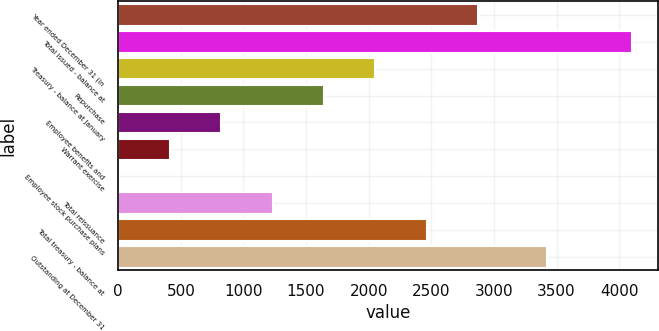Convert chart to OTSL. <chart><loc_0><loc_0><loc_500><loc_500><bar_chart><fcel>Year ended December 31 (in<fcel>Total issued - balance at<fcel>Treasury - balance at January<fcel>Repurchase<fcel>Employee benefits and<fcel>Warrant exercise<fcel>Employee stock purchase plans<fcel>Total reissuance<fcel>Total treasury - balance at<fcel>Outstanding at December 31<nl><fcel>2873.67<fcel>4104.9<fcel>2052.85<fcel>1642.44<fcel>821.62<fcel>411.21<fcel>0.8<fcel>1232.03<fcel>2463.26<fcel>3425.3<nl></chart> 